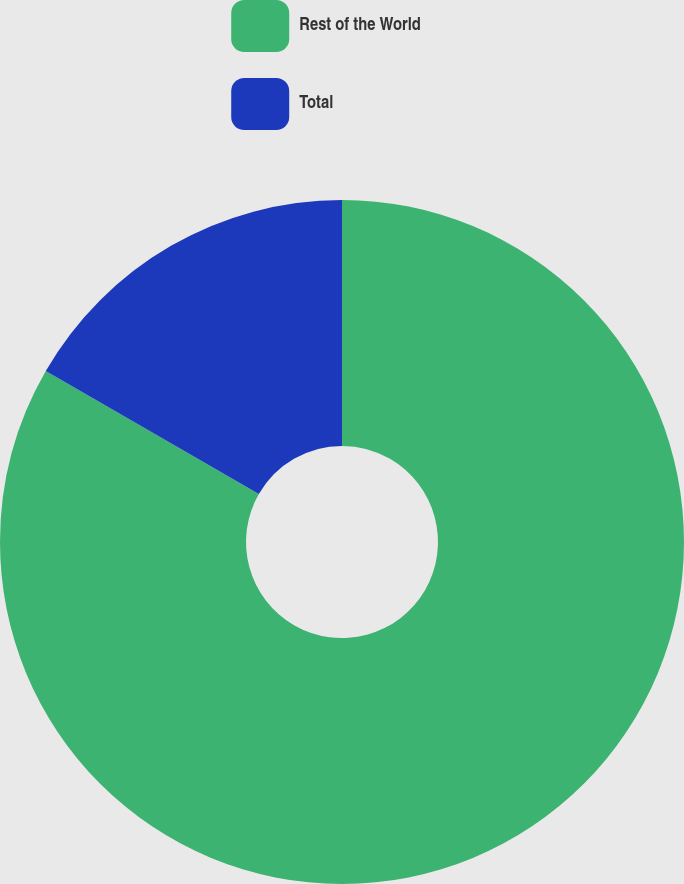Convert chart. <chart><loc_0><loc_0><loc_500><loc_500><pie_chart><fcel>Rest of the World<fcel>Total<nl><fcel>83.33%<fcel>16.67%<nl></chart> 